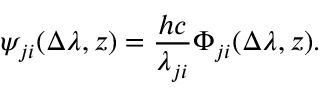Convert formula to latex. <formula><loc_0><loc_0><loc_500><loc_500>\psi _ { j i } ( \Delta \lambda , z ) = \frac { h c } { \lambda _ { j i } } \Phi _ { j i } ( \Delta \lambda , z ) .</formula> 